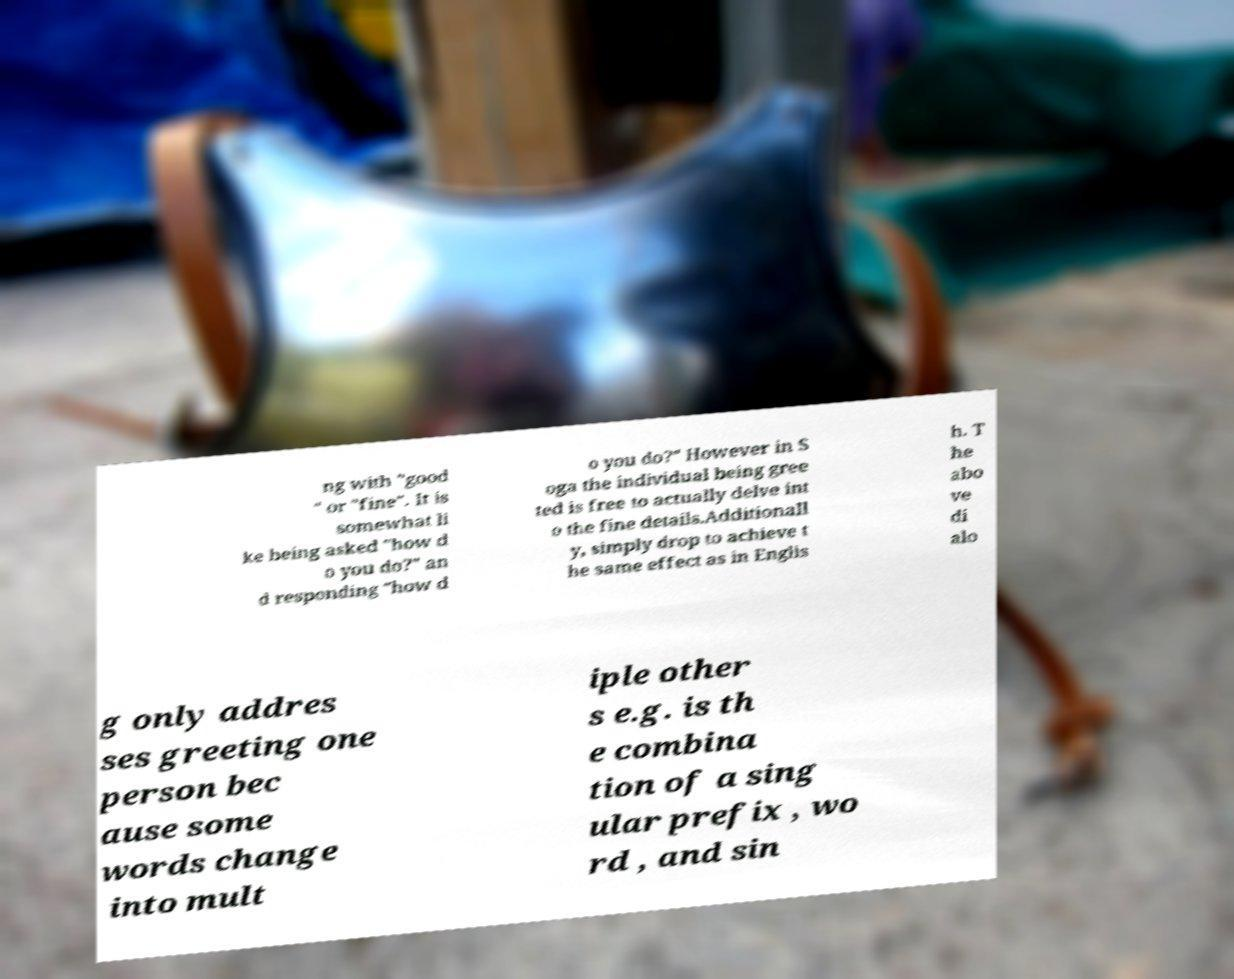Could you assist in decoding the text presented in this image and type it out clearly? ng with "good " or "fine". It is somewhat li ke being asked "how d o you do?" an d responding "how d o you do?" However in S oga the individual being gree ted is free to actually delve int o the fine details.Additionall y, simply drop to achieve t he same effect as in Englis h. T he abo ve di alo g only addres ses greeting one person bec ause some words change into mult iple other s e.g. is th e combina tion of a sing ular prefix , wo rd , and sin 